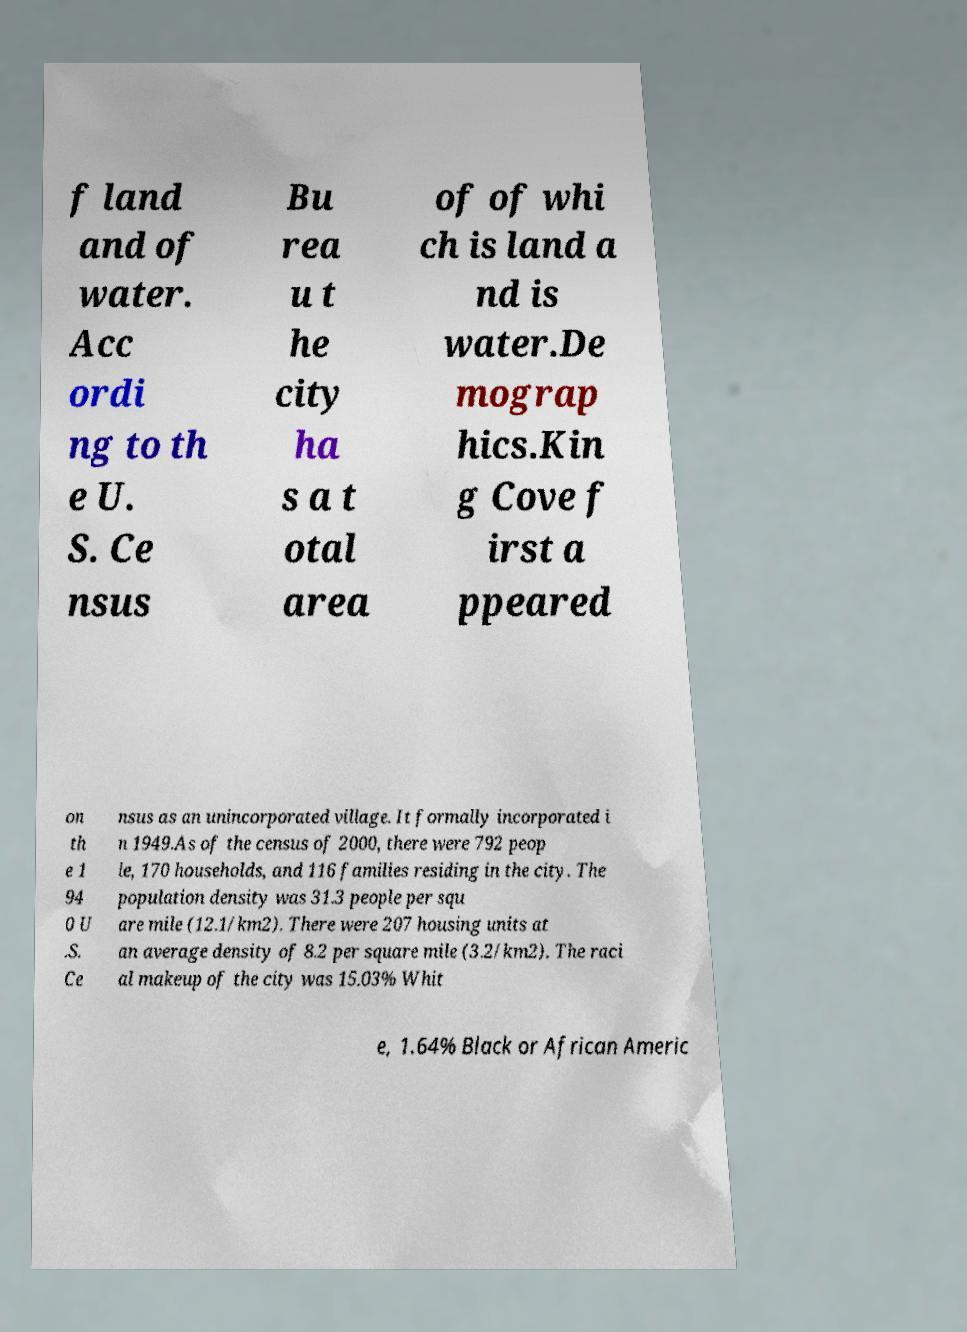Could you assist in decoding the text presented in this image and type it out clearly? f land and of water. Acc ordi ng to th e U. S. Ce nsus Bu rea u t he city ha s a t otal area of of whi ch is land a nd is water.De mograp hics.Kin g Cove f irst a ppeared on th e 1 94 0 U .S. Ce nsus as an unincorporated village. It formally incorporated i n 1949.As of the census of 2000, there were 792 peop le, 170 households, and 116 families residing in the city. The population density was 31.3 people per squ are mile (12.1/km2). There were 207 housing units at an average density of 8.2 per square mile (3.2/km2). The raci al makeup of the city was 15.03% Whit e, 1.64% Black or African Americ 